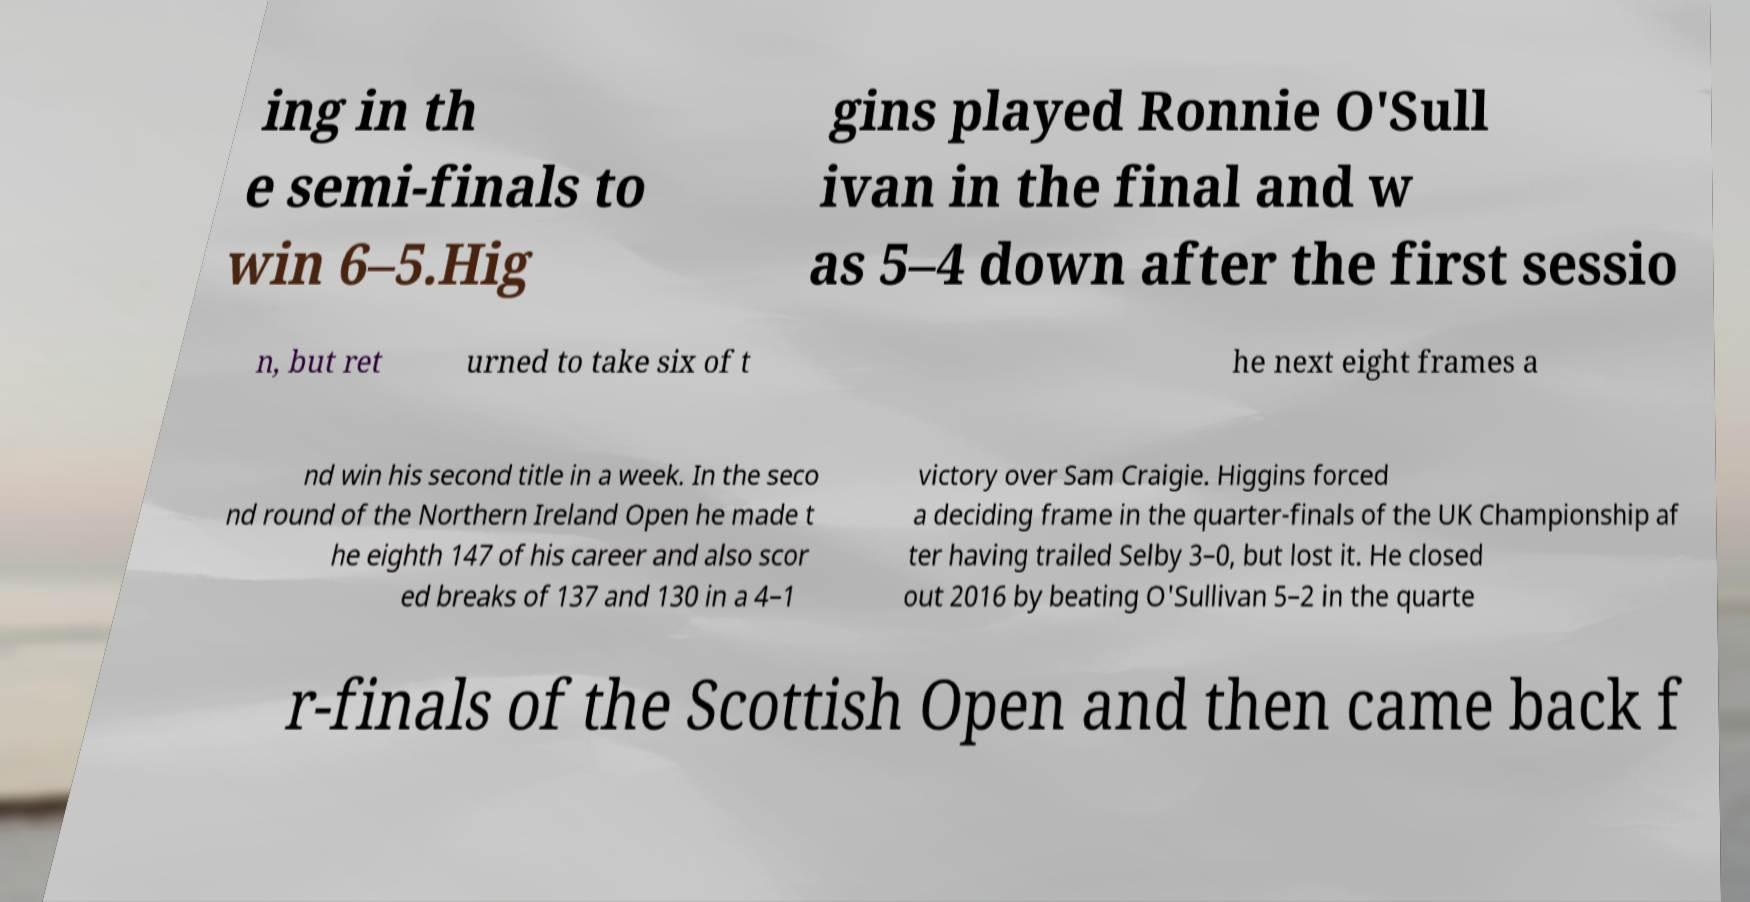Can you read and provide the text displayed in the image?This photo seems to have some interesting text. Can you extract and type it out for me? ing in th e semi-finals to win 6–5.Hig gins played Ronnie O'Sull ivan in the final and w as 5–4 down after the first sessio n, but ret urned to take six of t he next eight frames a nd win his second title in a week. In the seco nd round of the Northern Ireland Open he made t he eighth 147 of his career and also scor ed breaks of 137 and 130 in a 4–1 victory over Sam Craigie. Higgins forced a deciding frame in the quarter-finals of the UK Championship af ter having trailed Selby 3–0, but lost it. He closed out 2016 by beating O'Sullivan 5–2 in the quarte r-finals of the Scottish Open and then came back f 